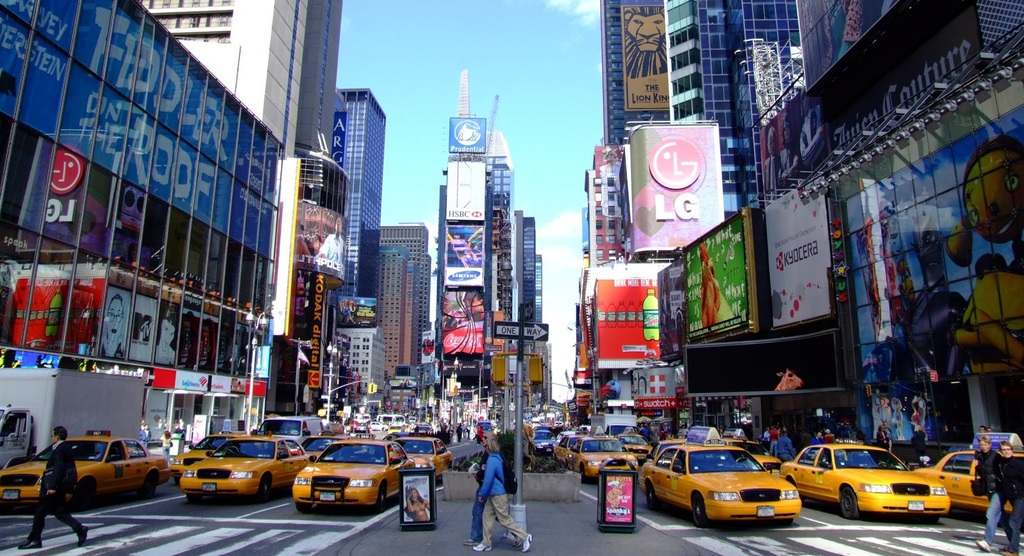Provide a one-sentence caption for the provided image. A vibrant street scene unfolds in Times Square, New York, bustling with yellow taxis and adorned with massive electronic billboards, prominently featuring an LG advertisement. 